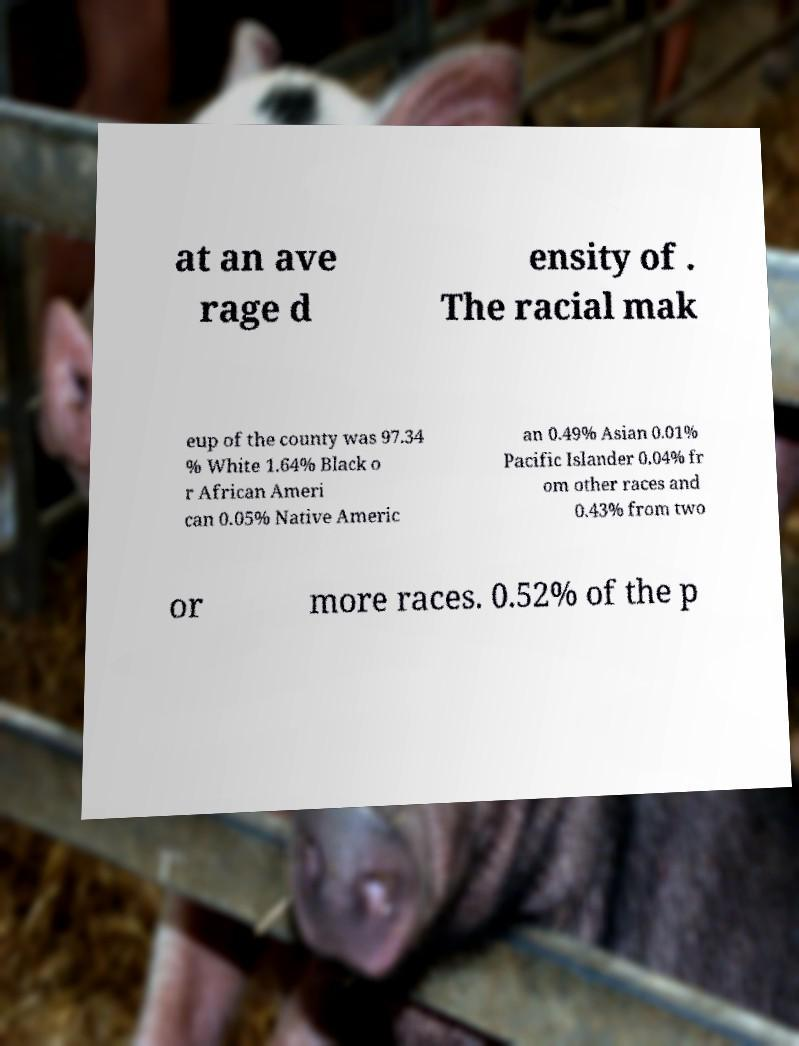Could you assist in decoding the text presented in this image and type it out clearly? at an ave rage d ensity of . The racial mak eup of the county was 97.34 % White 1.64% Black o r African Ameri can 0.05% Native Americ an 0.49% Asian 0.01% Pacific Islander 0.04% fr om other races and 0.43% from two or more races. 0.52% of the p 